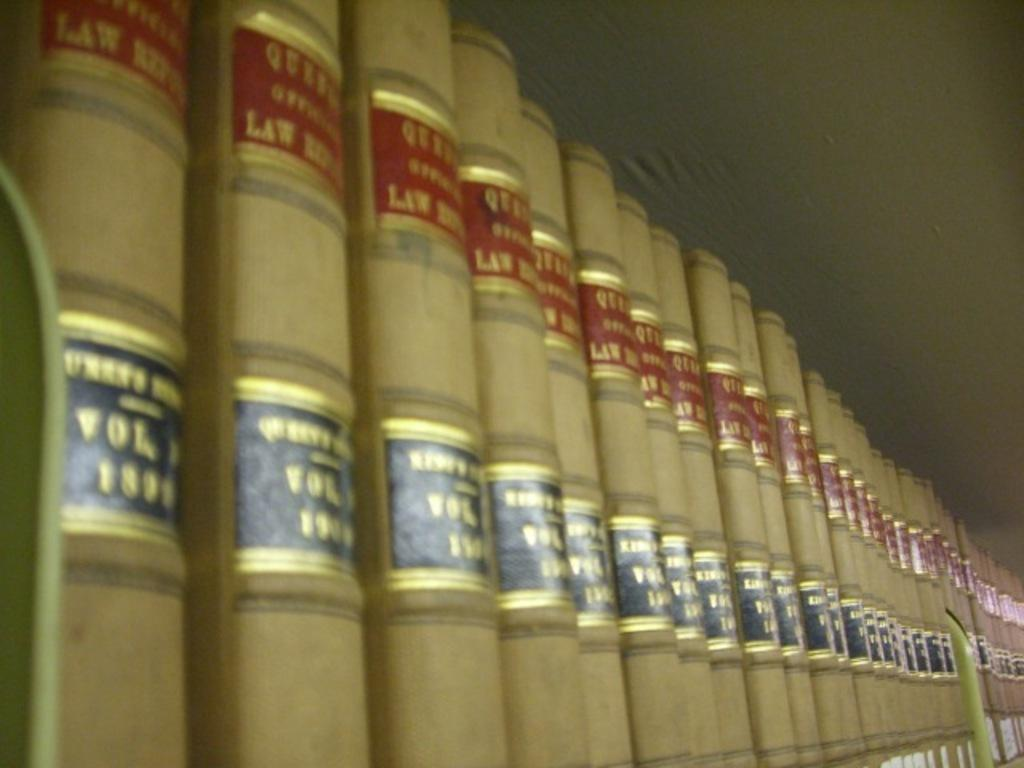Provide a one-sentence caption for the provided image. Tan with red and black Law books are lined up on a shelf. 